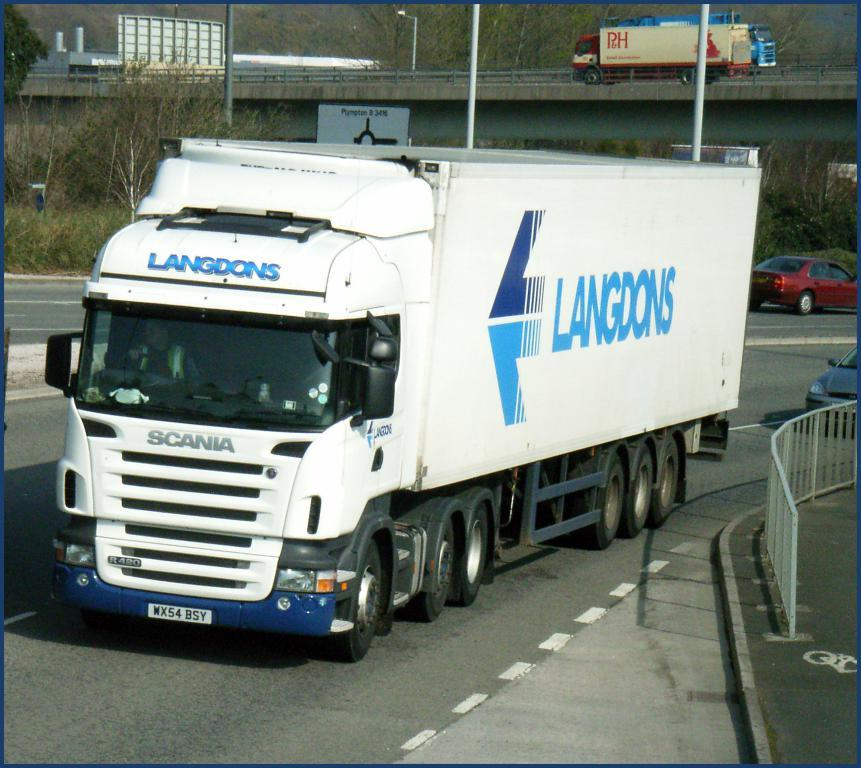What types of transportation are present in the image? Vehicles are on the road and bridge in the image. What safety feature can be seen in the image? There are railings in the image. What type of natural elements are visible in the image? Trees and plants are present in the image. What structures are in the image? Poles and boards are in the image. Can you describe the presence of a person in the image? There is a person inside a vehicle in the image. What type of ring is the person wearing in the image? There is no person wearing a ring in the image; the person is inside a vehicle. What type of building can be seen in the image? There is no building present in the image; the focus is on vehicles, railings, trees, plants, poles, boards, and a person inside a vehicle. 